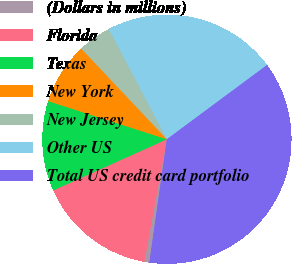<chart> <loc_0><loc_0><loc_500><loc_500><pie_chart><fcel>(Dollars in millions)<fcel>Florida<fcel>Texas<fcel>New York<fcel>New Jersey<fcel>Other US<fcel>Total US credit card portfolio<nl><fcel>0.66%<fcel>15.36%<fcel>11.68%<fcel>8.01%<fcel>4.33%<fcel>22.55%<fcel>37.4%<nl></chart> 